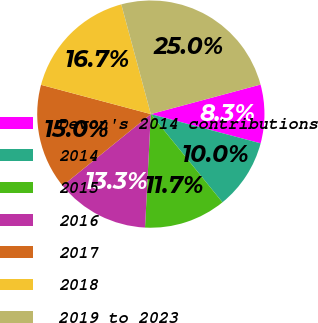Convert chart. <chart><loc_0><loc_0><loc_500><loc_500><pie_chart><fcel>Devon's 2014 contributions<fcel>2014<fcel>2015<fcel>2016<fcel>2017<fcel>2018<fcel>2019 to 2023<nl><fcel>8.33%<fcel>10.0%<fcel>11.67%<fcel>13.33%<fcel>15.0%<fcel>16.67%<fcel>25.0%<nl></chart> 